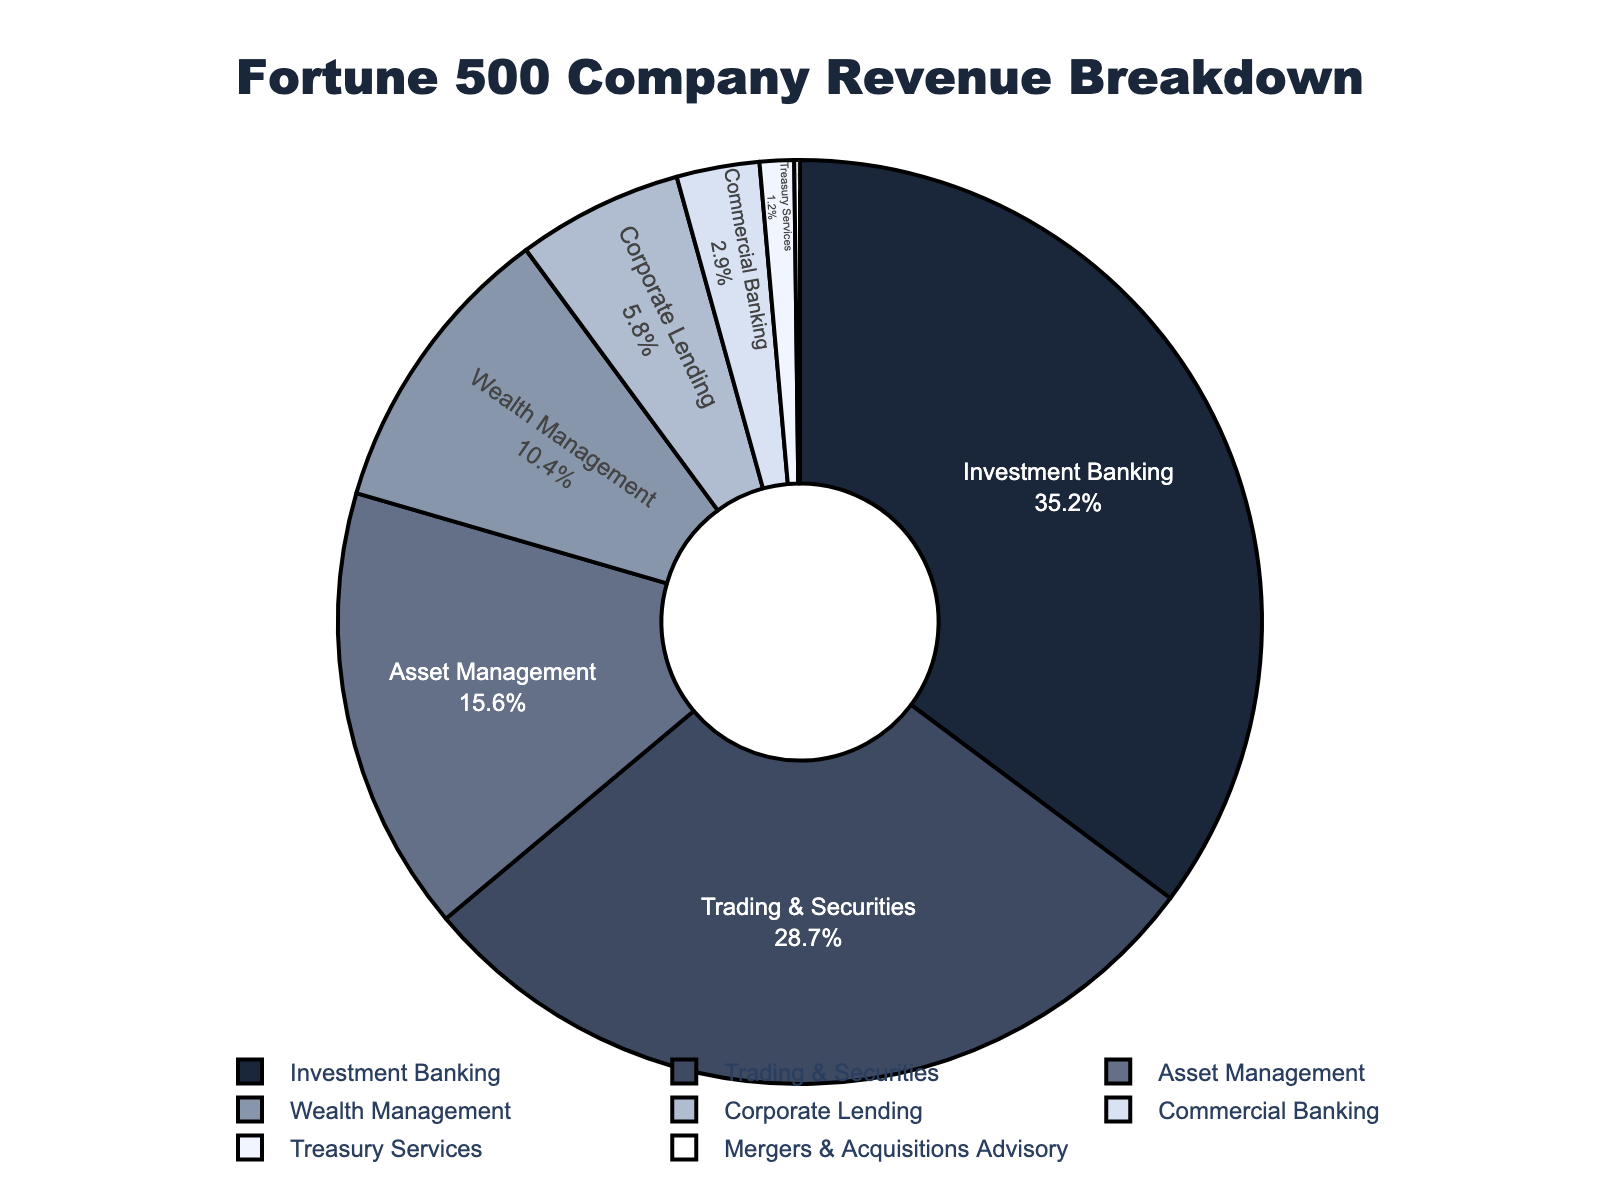what is the revenue percentage from Trading & Securities? The revenue percentage for Trading & Securities is directly labeled in the pie chart as 28.7%.
Answer: 28.7% which revenue source contributes the most to the overall revenue? By observing the pie chart, the largest segment is for Investment Banking, marked with a percentage of 35.2%.
Answer: Investment Banking how much more does Investment Banking contribute compared to Corporate Lending? The percentage for Investment Banking is 35.2% and for Corporate Lending is 5.8%. The difference is calculated as 35.2 - 5.8 = 29.4%.
Answer: 29.4% which color is used to represent Asset Management? The pie chart shows Asset Management in a segment colored in #637088 (a shade of blue).
Answer: blue what is the combined revenue percentage of Wealth Management and Commercial Banking? The chart shows Wealth Management with 10.4% and Commercial Banking with 2.9%. Adding these gives 10.4 + 2.9 = 13.3%.
Answer: 13.3% how much smaller is the Treasury Services segment compared to Trading & Securities? The chart shows Treasury Services with 1.2% and Trading & Securities with 28.7%. The difference is calculated as 28.7 - 1.2 = 27.5%.
Answer: 27.5% are there any revenue sources contributing less than 1%? Mergers & Acquisitions Advisory is shown with a contribution of 0.2%, which is less than 1%.
Answer: Yes, Mergers & Acquisitions Advisory what is the average percentage contribution of Corporate Lending and Treasury Services? Corporate Lending contributes 5.8% and Treasury Services contributes 1.2%. The average is calculated as (5.8 + 1.2) / 2 = 3.5%.
Answer: 3.5% which two revenue sources together amount to approximately one third of the total revenue? Trading & Securities (28.7%) and Asset Management (15.6%) together add up to 28.7 + 15.6 = 44.3%, which is more than one third. Instead, Investment Banking (35.2%) by itself is close to one third.
Answer: Investment Banking what is the least contributing revenue source and its percentage? The chart shows Mergers & Acquisitions Advisory as the least contributing source with 0.2%.
Answer: Mergers & Acquisitions Advisory 0.2% 